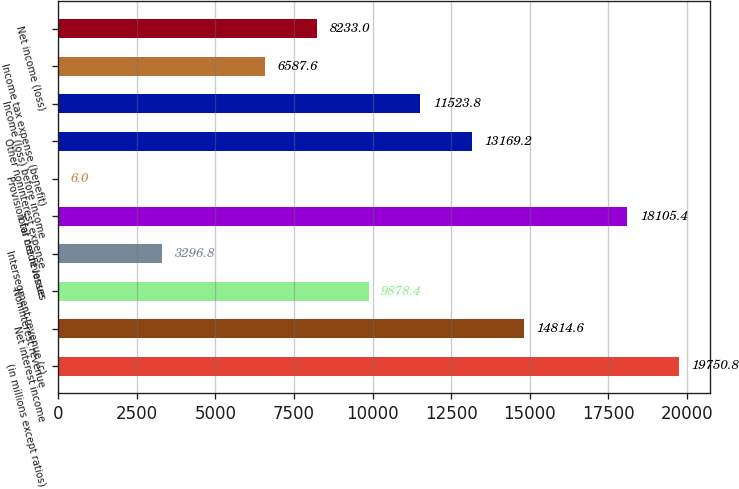Convert chart. <chart><loc_0><loc_0><loc_500><loc_500><bar_chart><fcel>(in millions except ratios)<fcel>Net interest income<fcel>Noninterest revenue<fcel>Intersegment revenue (c)<fcel>Total net revenue<fcel>Provision for credit losses<fcel>Other noninterest expense<fcel>Income (loss) before income<fcel>Income tax expense (benefit)<fcel>Net income (loss)<nl><fcel>19750.8<fcel>14814.6<fcel>9878.4<fcel>3296.8<fcel>18105.4<fcel>6<fcel>13169.2<fcel>11523.8<fcel>6587.6<fcel>8233<nl></chart> 